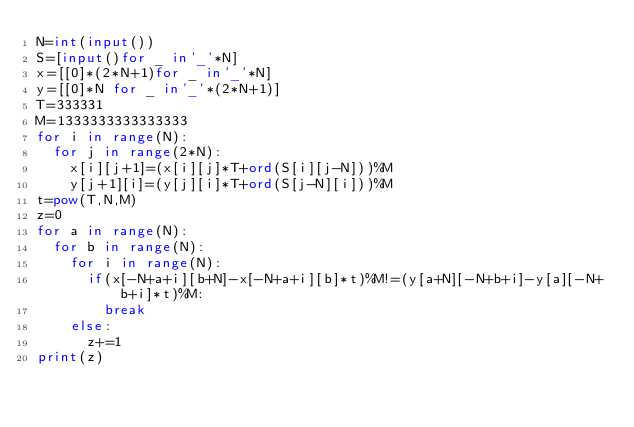<code> <loc_0><loc_0><loc_500><loc_500><_Python_>N=int(input())
S=[input()for _ in'_'*N]
x=[[0]*(2*N+1)for _ in'_'*N]
y=[[0]*N for _ in'_'*(2*N+1)]
T=333331
M=1333333333333333
for i in range(N):
	for j in range(2*N):
		x[i][j+1]=(x[i][j]*T+ord(S[i][j-N]))%M
		y[j+1][i]=(y[j][i]*T+ord(S[j-N][i]))%M
t=pow(T,N,M)
z=0
for a in range(N):
	for b in range(N):
		for i in range(N):
			if(x[-N+a+i][b+N]-x[-N+a+i][b]*t)%M!=(y[a+N][-N+b+i]-y[a][-N+b+i]*t)%M:
				break
		else:
			z+=1
print(z)
</code> 